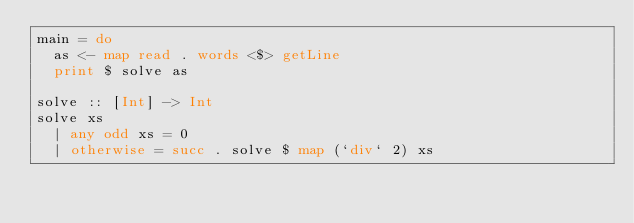<code> <loc_0><loc_0><loc_500><loc_500><_Haskell_>main = do
  as <- map read . words <$> getLine
  print $ solve as
 
solve :: [Int] -> Int
solve xs
  | any odd xs = 0
  | otherwise = succ . solve $ map (`div` 2) xs</code> 